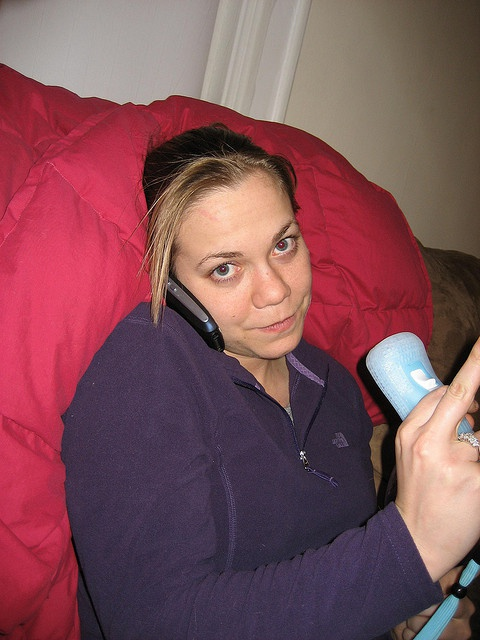Describe the objects in this image and their specific colors. I can see people in maroon, purple, black, and tan tones, couch in maroon and brown tones, remote in maroon, lightblue, and darkgray tones, and cell phone in maroon, black, and gray tones in this image. 